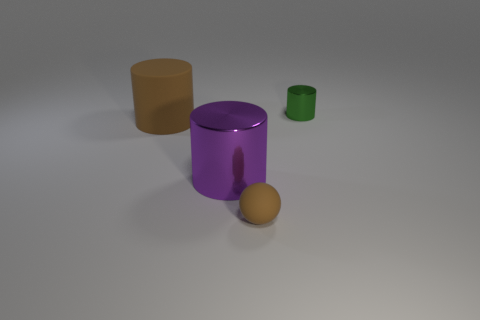Does the small rubber ball have the same color as the matte cylinder?
Your answer should be compact. Yes. The other matte object that is the same color as the big rubber thing is what size?
Offer a very short reply. Small. There is a purple shiny object; what shape is it?
Your answer should be very brief. Cylinder. There is a brown rubber thing on the left side of the big purple shiny cylinder that is to the left of the small thing that is in front of the tiny green thing; what shape is it?
Give a very brief answer. Cylinder. How many other things are the same shape as the small brown rubber thing?
Provide a short and direct response. 0. What material is the tiny object that is right of the small object that is to the left of the tiny green metal cylinder?
Make the answer very short. Metal. Is the material of the brown sphere the same as the large cylinder that is right of the big brown matte object?
Your response must be concise. No. There is a thing that is in front of the big matte thing and behind the rubber ball; what material is it?
Keep it short and to the point. Metal. There is a big cylinder that is behind the purple object that is in front of the big brown rubber cylinder; what color is it?
Make the answer very short. Brown. There is a tiny object in front of the large brown matte thing; what material is it?
Make the answer very short. Rubber. 